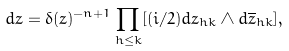Convert formula to latex. <formula><loc_0><loc_0><loc_500><loc_500>d z = \delta ( z ) ^ { - n + 1 } \prod _ { h \leq k } [ ( i / 2 ) d z _ { h k } \wedge d \overline { z } _ { h k } ] ,</formula> 